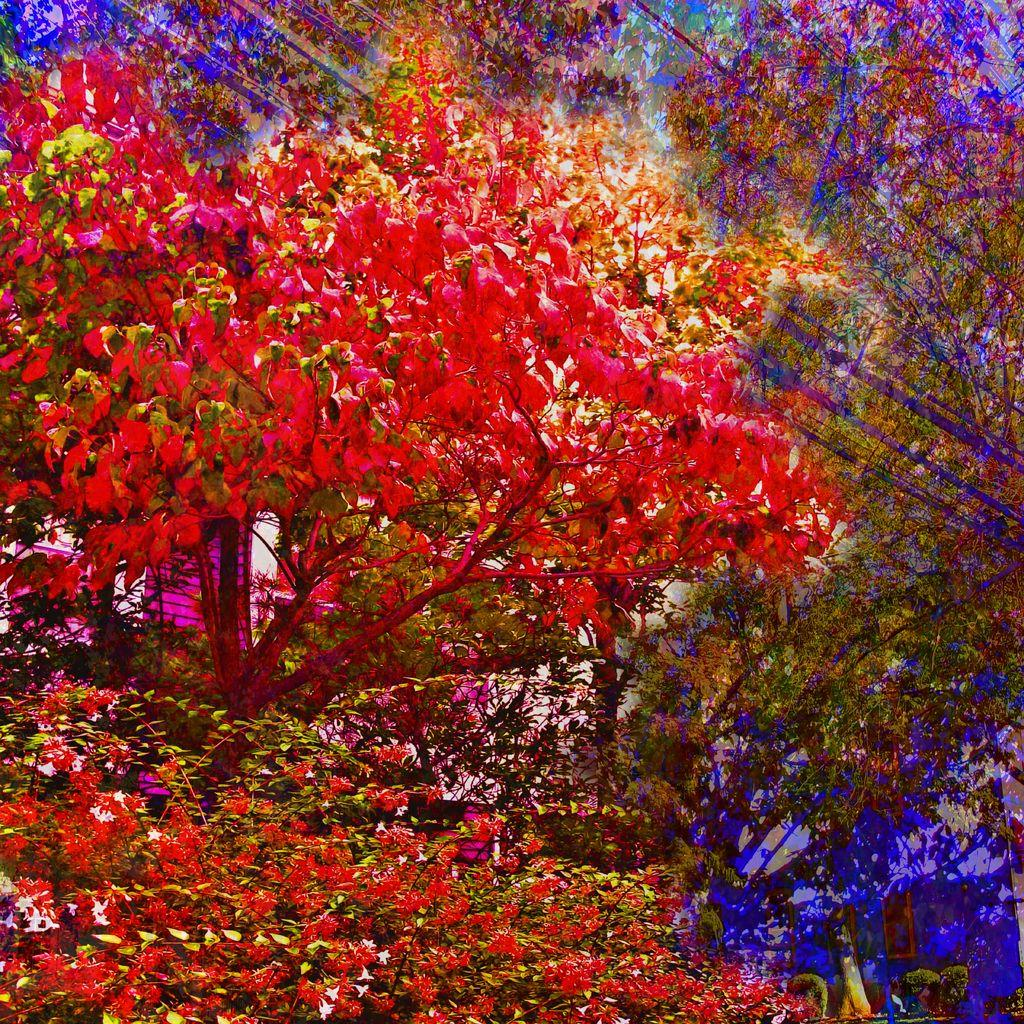What type of flowers are on the trees in the image? The flowers on the trees in the image are edited flowers. What color are the edited flowers? The edited flowers are in red color. What can be seen in the background of the image? The sky is visible in the image. Can you see the smile on the seed in the image? There is no seed or smile present in the image; it features edited red flowers on trees with a visible sky in the background. 